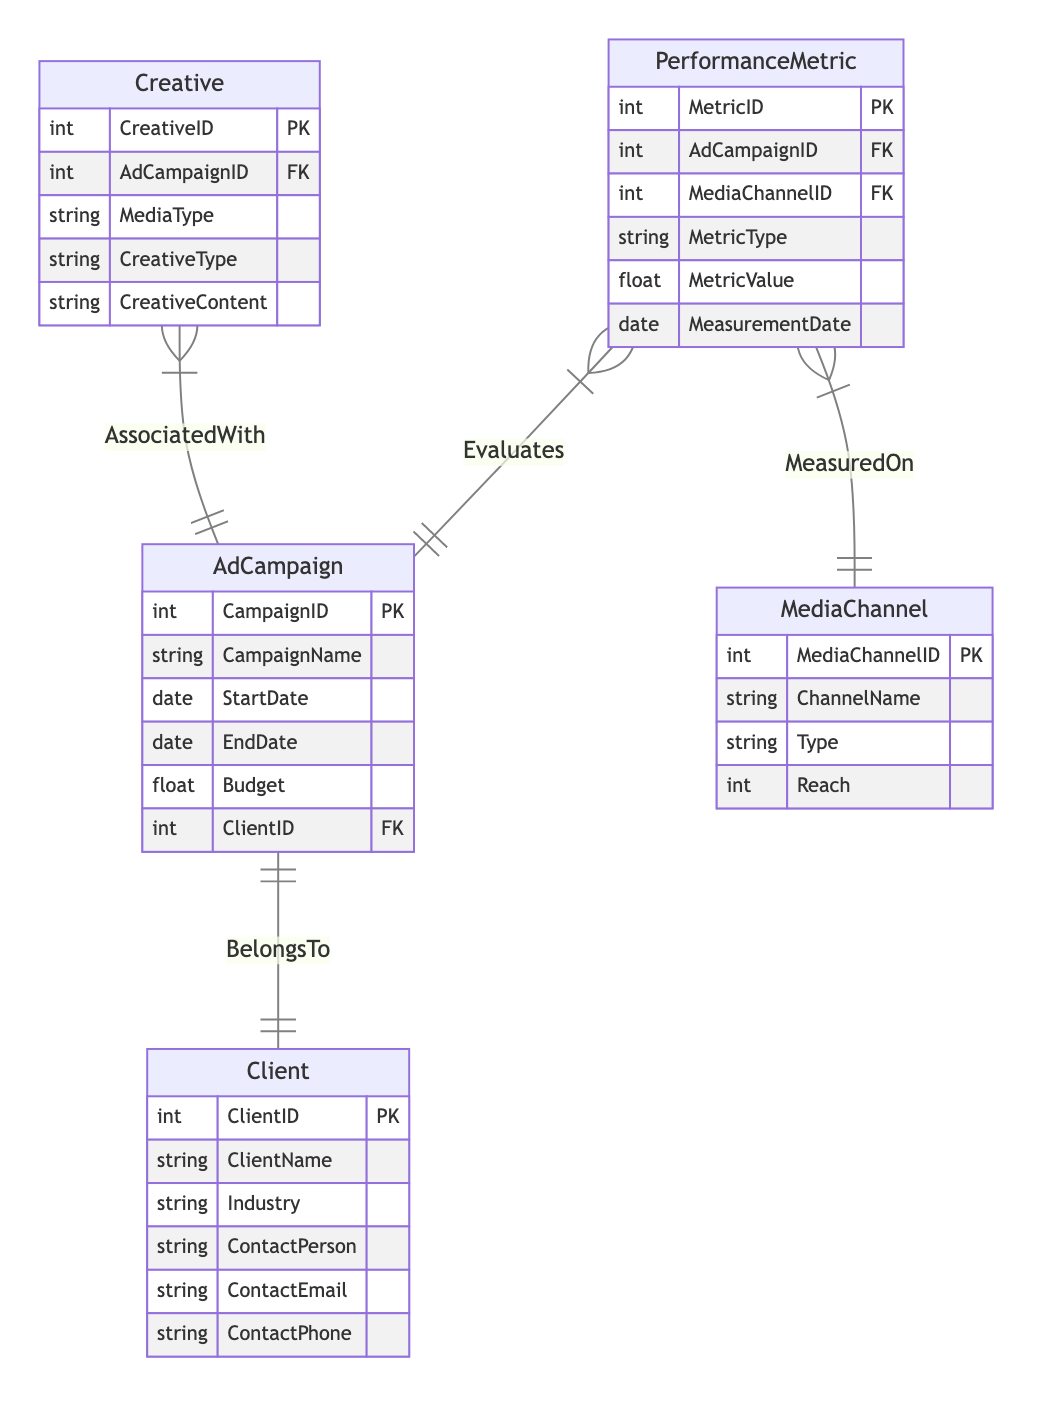What entities are included in the diagram? The diagram includes five entities: AdCampaign, Client, MediaChannel, Creative, and PerformanceMetric, as depicted in the 'entities' section of the data.
Answer: AdCampaign, Client, MediaChannel, Creative, PerformanceMetric How many relationships are there in total? The diagram outlines four distinct relationships between the entities, as listed in the 'relationships' section.
Answer: Four What is the primary key of the AdCampaign entity? The 'AdCampaign' entity specifies that the primary key is CampaignID, which is indicated by the notation PK next to it.
Answer: CampaignID Between which two entities is the "BelongsTo" relationship defined? The 'relationships' section reveals that the "BelongsTo" relationship is defined between AdCampaign and Client, specifying that each AdCampaign is associated with one Client.
Answer: AdCampaign, Client What attributes does the MediaChannel entity possess? The MediaChannel entity has four attributes: MediaChannelID, ChannelName, Type, and Reach, which are enumerated under the MediaChannel entity in the diagram.
Answer: MediaChannelID, ChannelName, Type, Reach How is the PerformanceMetric entity related to MediaChannel? The relationship labeled "MeasuredOn" indicates that the PerformanceMetric entity is associated with the MediaChannel entity, meaning that performance metrics are measured based on specific media channels.
Answer: MeasuredOn Which entity evaluates the PerformanceMetric? According to the relationships, the PerformanceMetric entity evaluates the AdCampaign entity, signifying that each PerformanceMetric corresponds to an AdCampaign.
Answer: AdCampaign What type of relationship exists between Creative and AdCampaign entities? The diagram designates the relationship type as "AssociatedWith," meaning that each Creative is related to one AdCampaign in a way that associates the two entities directly.
Answer: AssociatedWith What attribute in the Client entity is used to identify a contact? The Client entity includes an attribute named ContactPerson, which serves to identify the individual responsible for communication related to the Client.
Answer: ContactPerson 